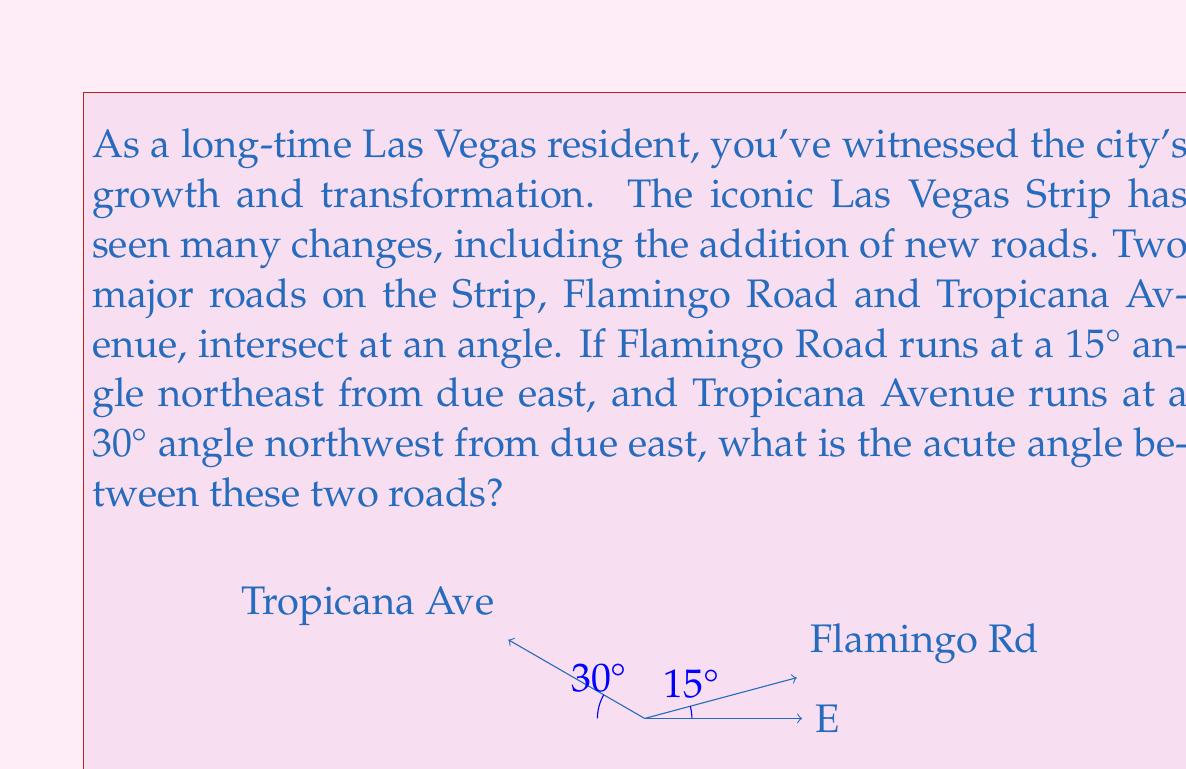Teach me how to tackle this problem. To solve this problem, we need to understand that the angle between two intersecting roads is the difference between their individual angles from a common reference line. In this case, we'll use due east as our reference.

Let's break it down step-by-step:

1) Flamingo Road runs at a 15° angle northeast from due east. This means it makes a 15° angle with the east direction.

2) Tropicana Avenue runs at a 30° angle northwest from due east. To find its angle from east, we need to subtract this from 180°:
   $180° - 30° = 150°$

3) Now we have both roads' angles from east:
   Flamingo Road: 15°
   Tropicana Avenue: 150°

4) To find the angle between these roads, we subtract the smaller angle from the larger angle:
   $150° - 15° = 135°$

5) However, the question asks for the acute angle. In geometry, when two lines intersect, they form two pairs of equal angles. The acute angle is always less than or equal to 90°. To find the acute angle, we subtract our result from 180°:
   $180° - 135° = 45°$

Therefore, the acute angle between Flamingo Road and Tropicana Avenue is 45°.
Answer: The acute angle between Flamingo Road and Tropicana Avenue is 45°. 